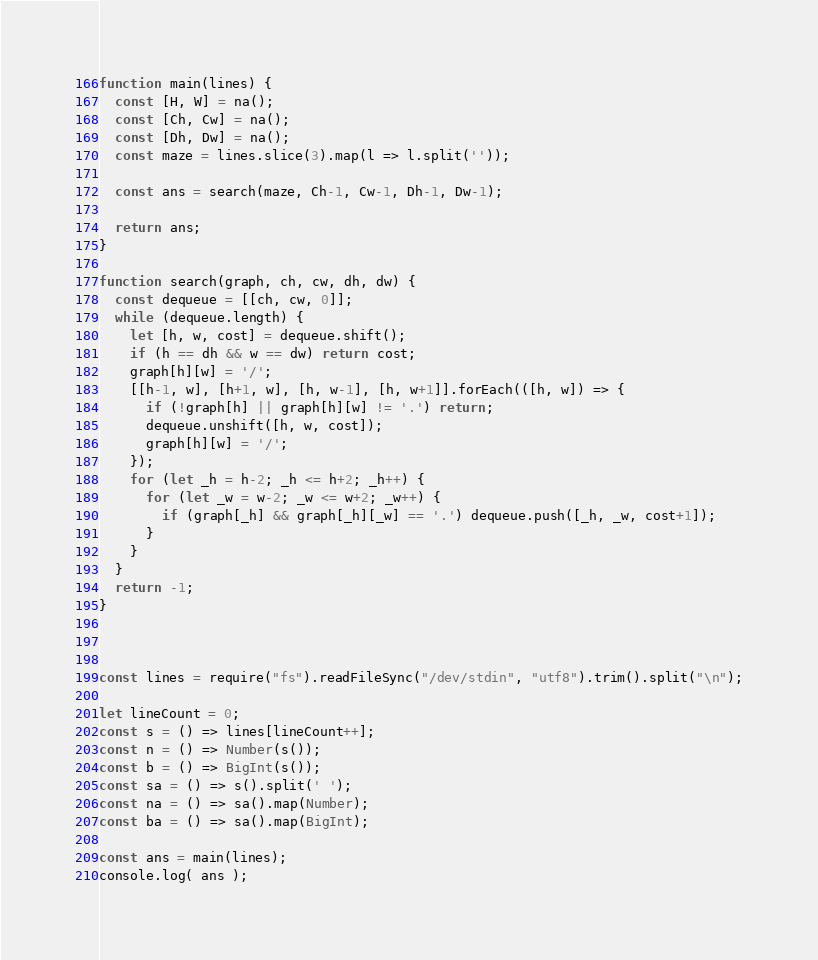Convert code to text. <code><loc_0><loc_0><loc_500><loc_500><_JavaScript_>function main(lines) {
  const [H, W] = na();
  const [Ch, Cw] = na();
  const [Dh, Dw] = na();
  const maze = lines.slice(3).map(l => l.split(''));
  
  const ans = search(maze, Ch-1, Cw-1, Dh-1, Dw-1);
  
  return ans;
}

function search(graph, ch, cw, dh, dw) {
  const dequeue = [[ch, cw, 0]];
  while (dequeue.length) {
    let [h, w, cost] = dequeue.shift();
    if (h == dh && w == dw) return cost;
    graph[h][w] = '/';
    [[h-1, w], [h+1, w], [h, w-1], [h, w+1]].forEach(([h, w]) => {
      if (!graph[h] || graph[h][w] != '.') return;
      dequeue.unshift([h, w, cost]);
      graph[h][w] = '/';
    });
    for (let _h = h-2; _h <= h+2; _h++) {
      for (let _w = w-2; _w <= w+2; _w++) {
        if (graph[_h] && graph[_h][_w] == '.') dequeue.push([_h, _w, cost+1]);
      }
    }
  }
  return -1;
}



const lines = require("fs").readFileSync("/dev/stdin", "utf8").trim().split("\n");

let lineCount = 0;
const s = () => lines[lineCount++];
const n = () => Number(s());
const b = () => BigInt(s());
const sa = () => s().split(' ');
const na = () => sa().map(Number);
const ba = () => sa().map(BigInt);

const ans = main(lines);
console.log( ans );</code> 